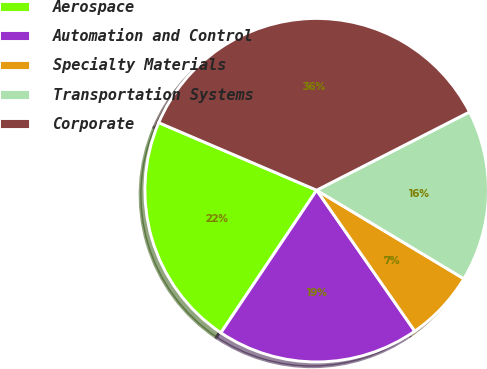Convert chart to OTSL. <chart><loc_0><loc_0><loc_500><loc_500><pie_chart><fcel>Aerospace<fcel>Automation and Control<fcel>Specialty Materials<fcel>Transportation Systems<fcel>Corporate<nl><fcel>22.02%<fcel>19.09%<fcel>6.7%<fcel>16.15%<fcel>36.04%<nl></chart> 